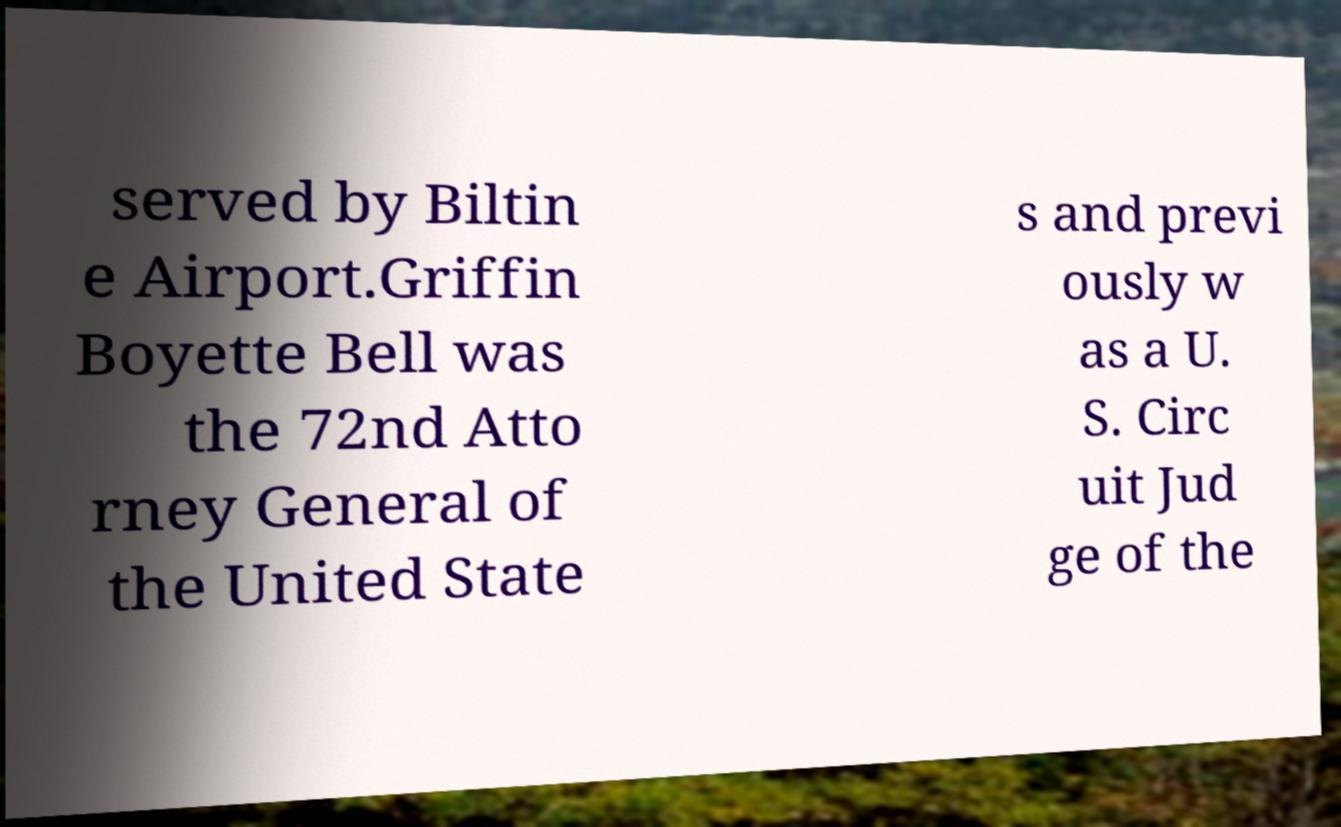What messages or text are displayed in this image? I need them in a readable, typed format. served by Biltin e Airport.Griffin Boyette Bell was the 72nd Atto rney General of the United State s and previ ously w as a U. S. Circ uit Jud ge of the 